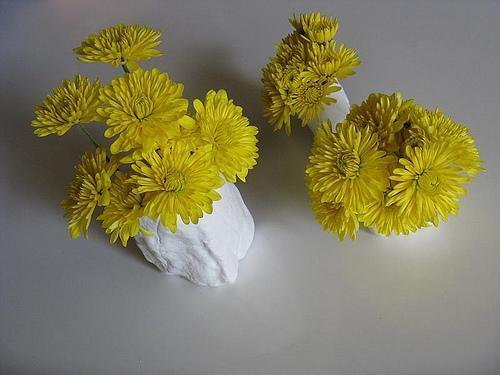How many groups of flowers are there?
Give a very brief answer. 3. 